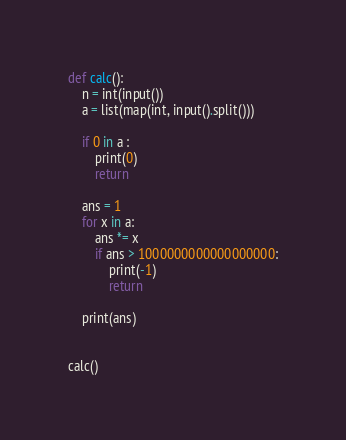<code> <loc_0><loc_0><loc_500><loc_500><_Python_>def calc():
    n = int(input())
    a = list(map(int, input().split()))

    if 0 in a :
        print(0)
        return

    ans = 1
    for x in a:
        ans *= x
        if ans > 1000000000000000000:
            print(-1)
            return

    print(ans)


calc()
</code> 